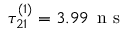Convert formula to latex. <formula><loc_0><loc_0><loc_500><loc_500>\tau _ { 2 1 } ^ { ( 1 ) } = 3 . 9 9 \, n s</formula> 